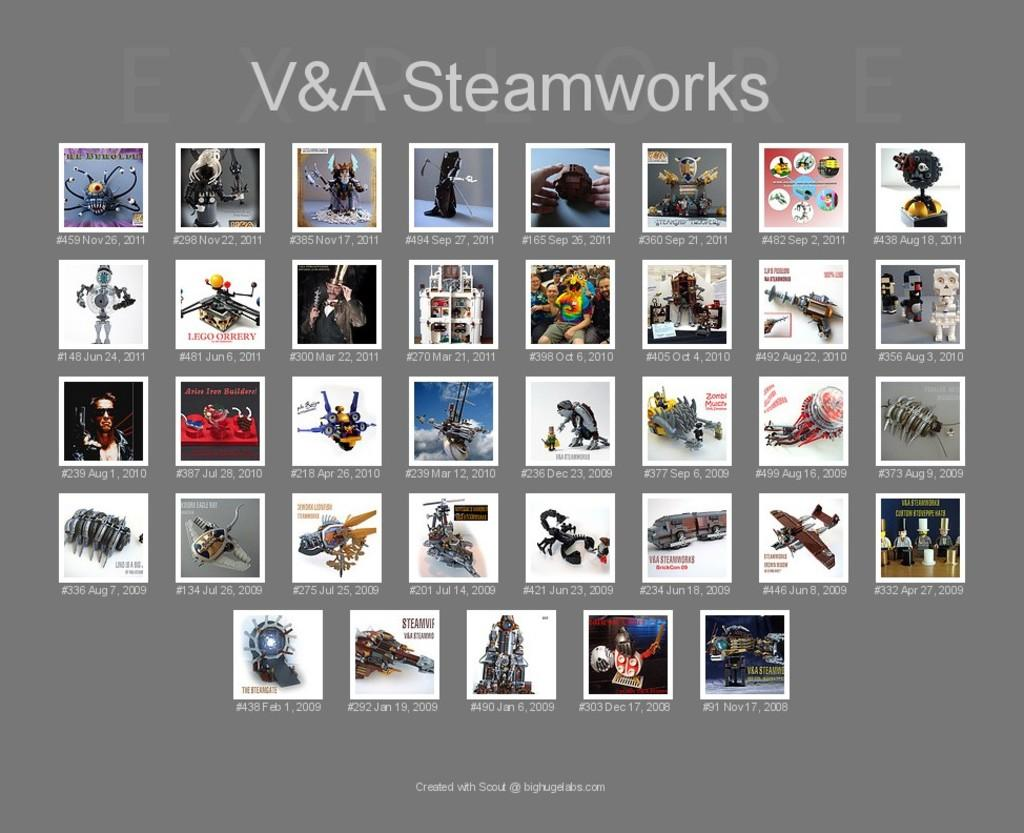Provide a one-sentence caption for the provided image. The picture collage is titled V&A Steamworks and has photos taken from 2008 to 2011.. 